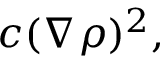<formula> <loc_0><loc_0><loc_500><loc_500>c ( \nabla \rho ) ^ { 2 } ,</formula> 